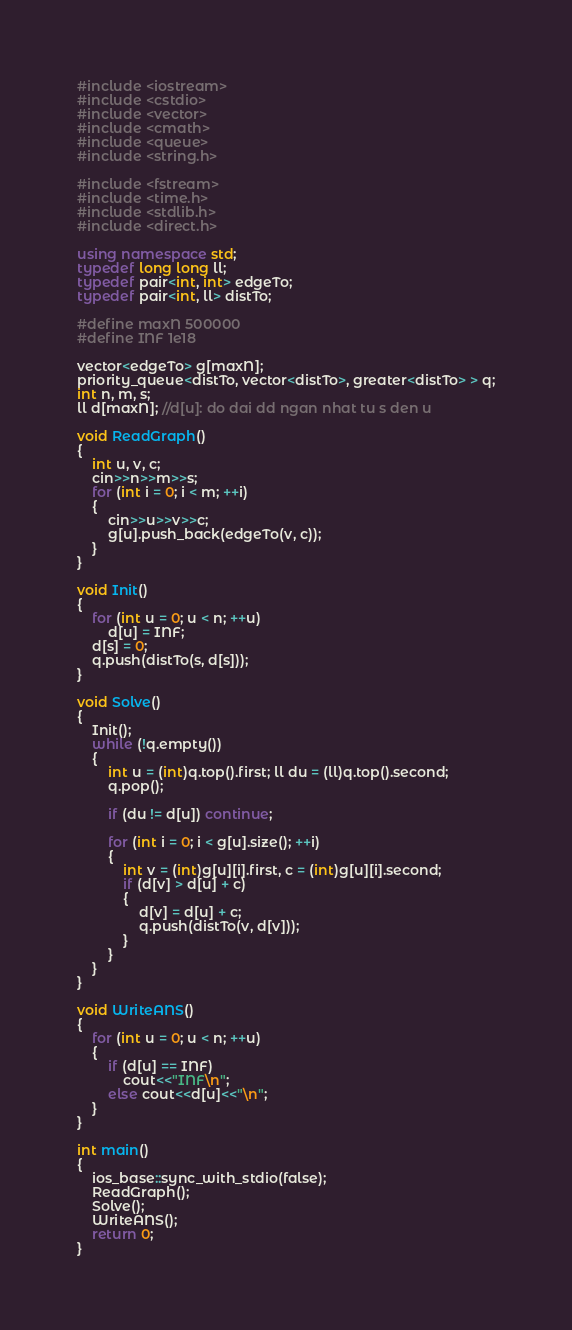<code> <loc_0><loc_0><loc_500><loc_500><_C++_>#include <iostream>
#include <cstdio>
#include <vector>
#include <cmath>
#include <queue>
#include <string.h>

#include <fstream>
#include <time.h>
#include <stdlib.h>
#include <direct.h>

using namespace std;
typedef long long ll;
typedef pair<int, int> edgeTo;
typedef pair<int, ll> distTo;

#define maxN 500000
#define INF 1e18

vector<edgeTo> g[maxN];
priority_queue<distTo, vector<distTo>, greater<distTo> > q;
int n, m, s;
ll d[maxN]; //d[u]: do dai dd ngan nhat tu s den u

void ReadGraph()
{
    int u, v, c;
    cin>>n>>m>>s;
    for (int i = 0; i < m; ++i)
    {
        cin>>u>>v>>c;
        g[u].push_back(edgeTo(v, c));
    }
}

void Init()
{
    for (int u = 0; u < n; ++u)
        d[u] = INF;
    d[s] = 0;
    q.push(distTo(s, d[s]));
}

void Solve()
{
    Init();
    while (!q.empty())
    {
        int u = (int)q.top().first; ll du = (ll)q.top().second;
        q.pop();

        if (du != d[u]) continue;

        for (int i = 0; i < g[u].size(); ++i)
        {
            int v = (int)g[u][i].first, c = (int)g[u][i].second;
            if (d[v] > d[u] + c)
            {
                d[v] = d[u] + c;
                q.push(distTo(v, d[v]));
            }
        }
    }
}

void WriteANS()
{
    for (int u = 0; u < n; ++u)
    {
        if (d[u] == INF)
            cout<<"INF\n";
        else cout<<d[u]<<"\n";
    }
}

int main()
{
    ios_base::sync_with_stdio(false);
    ReadGraph();
    Solve();
    WriteANS();
    return 0;
}</code> 